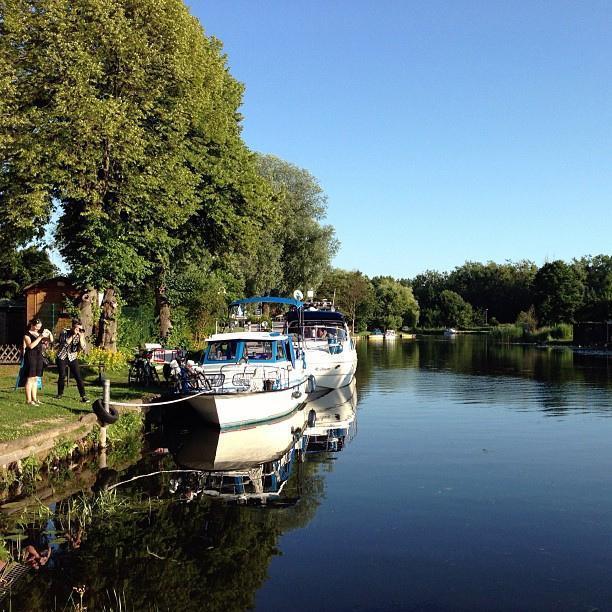How many boats are in the picture?
Give a very brief answer. 2. How many boats are in the photo?
Give a very brief answer. 2. 